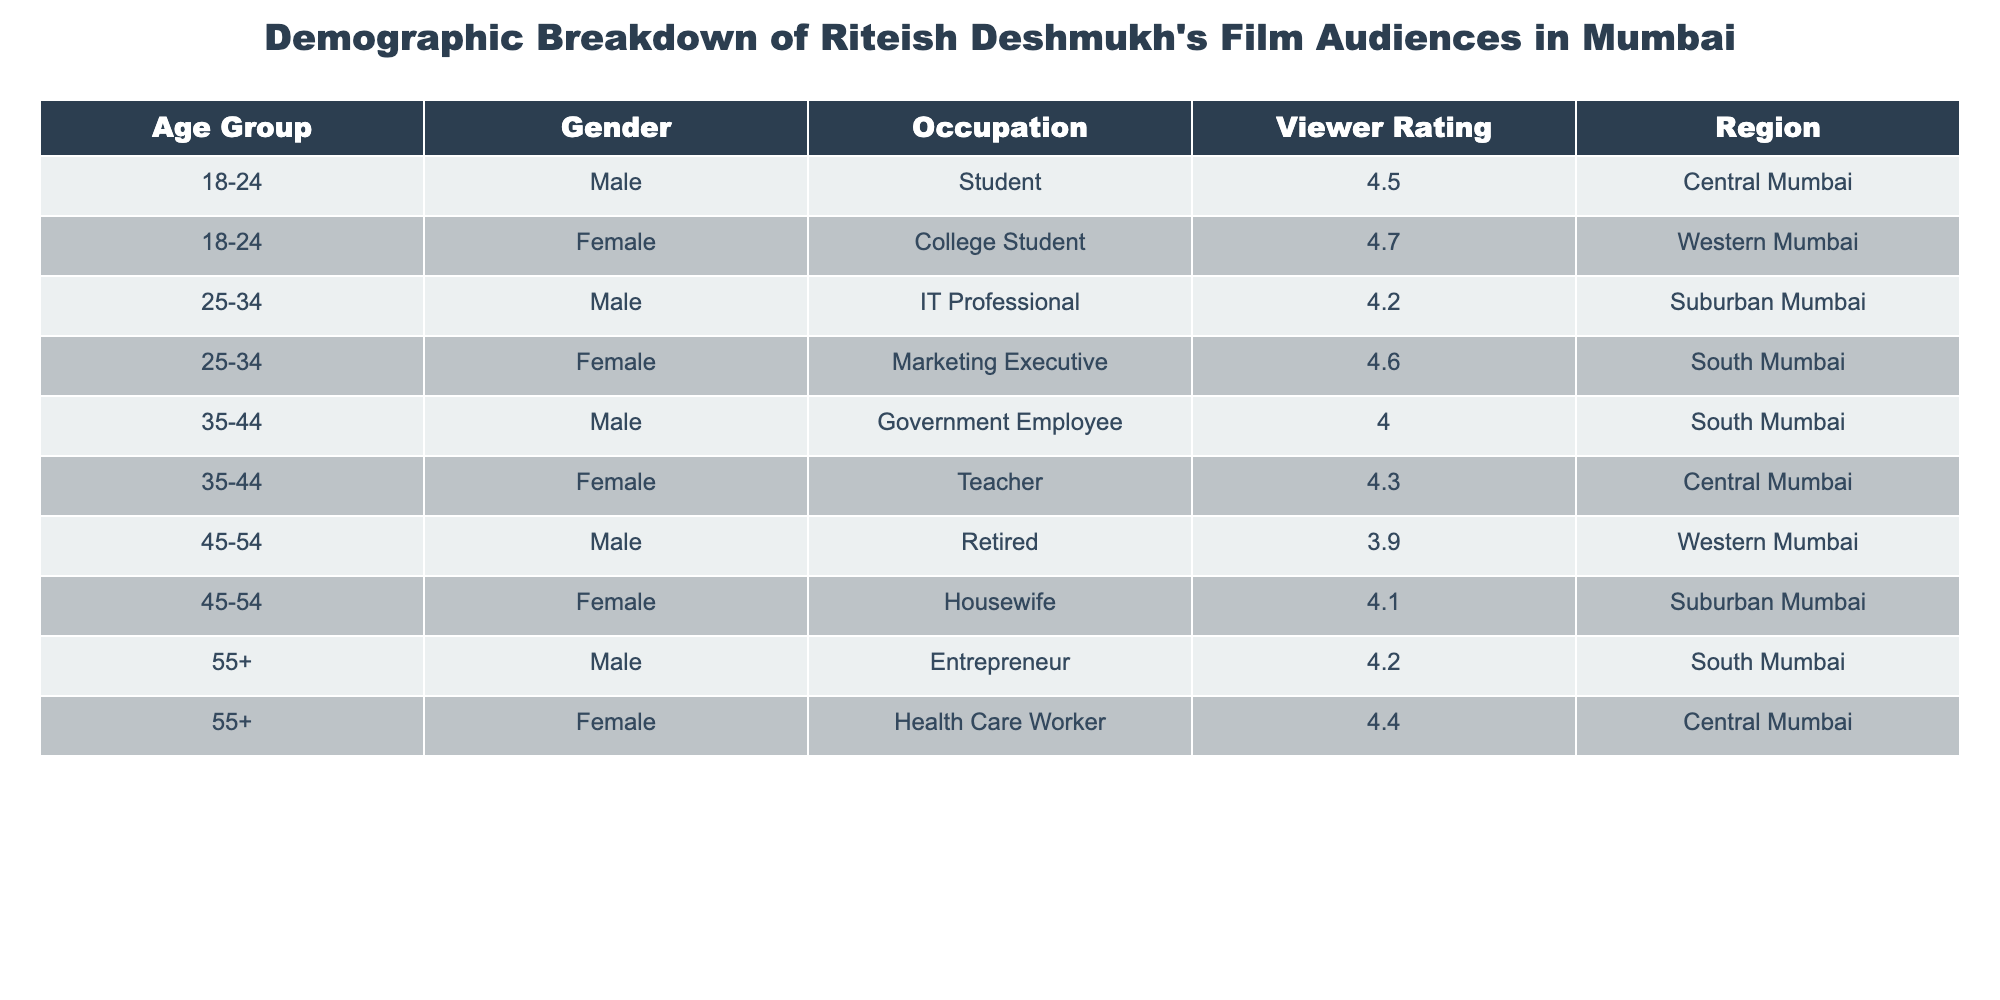What is the viewer rating for female college students in Western Mumbai? The table shows that the viewer rating for female college students in Western Mumbai is 4.7.
Answer: 4.7 What age group has the highest viewer rating on average? To find this, calculate the average viewer rating for each age group: 18-24 (4.6), 25-34 (4.4), 35-44 (4.15), 45-54 (4.0), and 55+ (4.3). The highest average is for the 18-24 age group at 4.6.
Answer: 18-24 Is there any female audience member with a viewer rating below 4.0? Yes, there is one: the retired male has a rating of 3.9, but he is not female. The housewife in the 45-54 age group has a rating of 4.1, which is above 4.0. Therefore, the answer is no.
Answer: No What is the total number of male viewers in the age group 35-44? According to the table, there is one male in the 35-44 age group, which is a government employee. Therefore, the total is 1.
Answer: 1 What is the difference in viewer ratings between the youngest (18-24) and the oldest (55+) age groups? The viewer rating for the youngest age group (18-24) is 4.6, while the oldest age group (55+) has a rating of 4.3. The difference is calculated as 4.6 - 4.3 = 0.3.
Answer: 0.3 Are there more female audience members than male audience members overall? Counting females: 4 (female college student, marketing executive, teacher, housewife, health care worker) and males: 5 (student, IT professional, government employee, retired, entrepreneur). Since 5 > 4, the answer is no.
Answer: No What age group has the highest viewer rating for female viewers? Among females, the age groups are: 18-24 (4.7), 25-34 (4.6), 35-44 (4.3), 45-54 (4.1), and 55+ (4.4). The highest viewer rating is for the 18-24 age group at 4.7.
Answer: 18-24 What is the average viewer rating of both male and female audiences aged 25-34? For males in this group, the rating is 4.2. For females, it is 4.6. The average is calculated as (4.2 + 4.6) / 2 = 4.4.
Answer: 4.4 